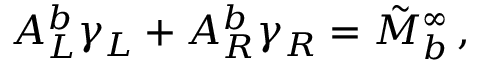<formula> <loc_0><loc_0><loc_500><loc_500>A _ { L } ^ { b } \gamma _ { L } + A _ { R } ^ { b } \gamma _ { R } = \tilde { M } _ { b } ^ { \infty } \, ,</formula> 